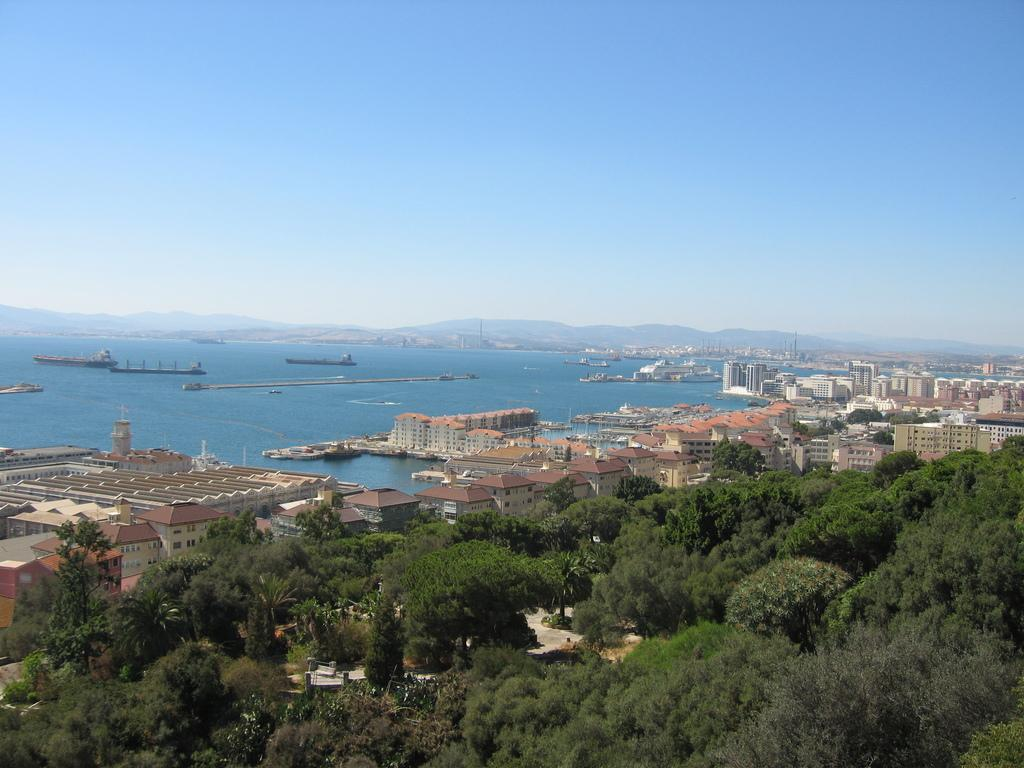What type of natural vegetation can be seen in the image? There are trees in the image. What type of man-made structures are present in the image? There are buildings in the image. What type of transportation is depicted in the image? There are boats in the image. What is the body of water in the image? There is water visible in the image. What is visible at the top of the image? The sky is visible at the top of the image. What type of business is being conducted in the image? There is no indication of any business activity in the image. What riddle can be solved by looking at the image? There is no riddle present in the image. 